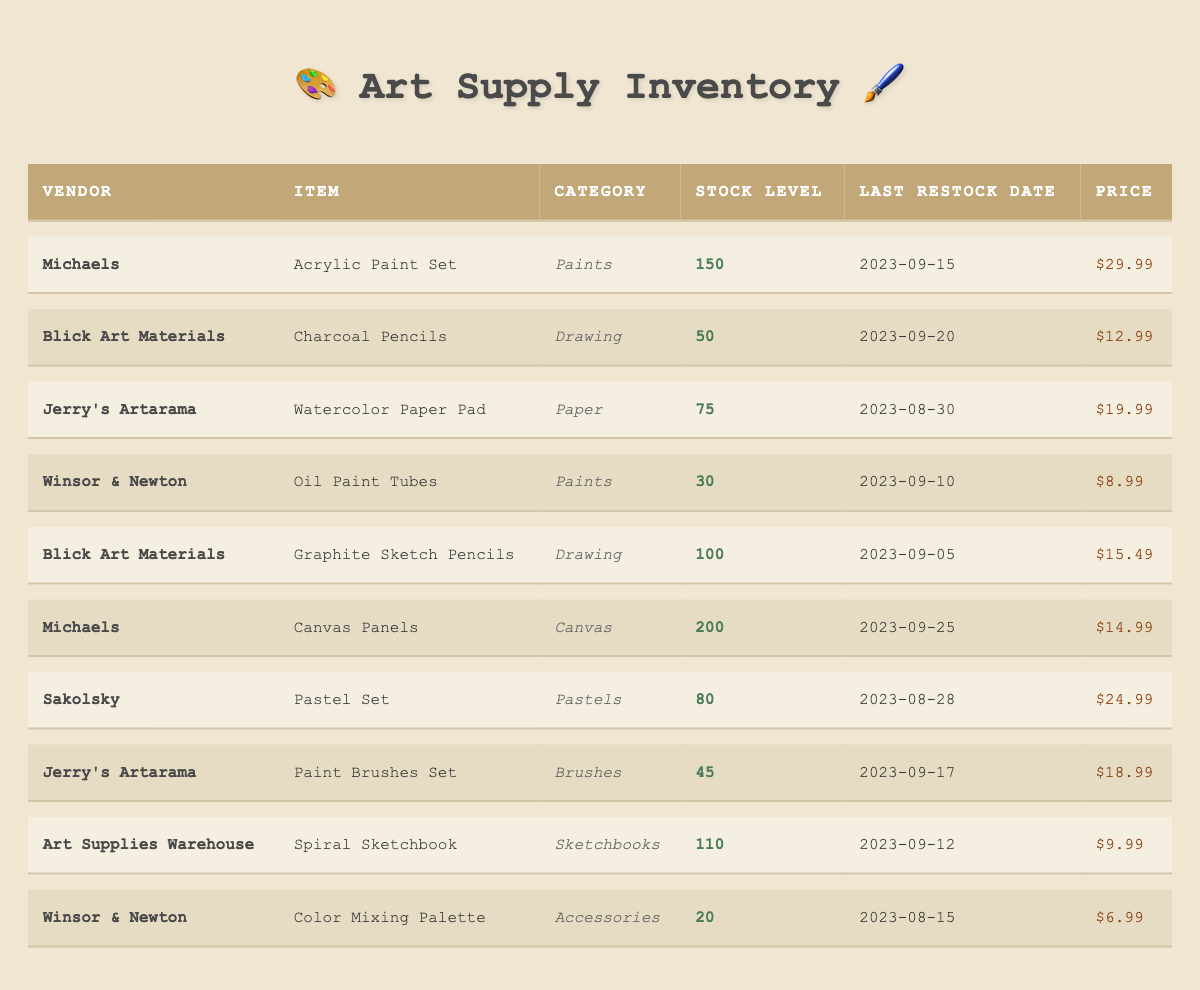What is the stock level of the Canvas Panels from Michaels? The table shows a stock level number for each item. Looking specifically at the row for Michaels' Canvas Panels, the stock level is 200.
Answer: 200 Which item has the lowest stock level? I review the stock levels of all items listed. The lowest stock level is 20 for Winsor & Newton's Color Mixing Palette.
Answer: 20 How many items from Blick Art Materials are listed in the table? By scanning the vendor column, I find that Blick Art Materials appears for two items: Charcoal Pencils and Graphite Sketch Pencils. Hence, there are 2 items from Blick Art Materials.
Answer: 2 What is the average price of the items listed under the category 'Paints'? I find the items categorized as 'Paints': Acrylic Paint Set ($29.99) and Oil Paint Tubes ($8.99). I sum their prices: 29.99 + 8.99 = 38.98. There are 2 items, so the average is 38.98 / 2 = 19.49.
Answer: 19.49 Is there more stock available for Graphite Sketch Pencils than for Watercolor Paper Pad? The stock level for Graphite Sketch Pencils is 100, while for Watercolor Paper Pad, it is 75. Since 100 > 75, the statement is true.
Answer: Yes Which vendor has the highest stock level across all their items in this table? I check each vendor and their stock levels. Michaels has 150 (Acrylic Paint Set) + 200 (Canvas Panels) = 350, Blick Art Materials has 50 + 100 = 150, Jerry's Artarama has 75 + 45 = 120, Winsor & Newton has 30 + 20 = 50, and Sakolsky has 80. Michaels leads with 350, thus it has the highest stock.
Answer: Michaels How much would it cost to purchase one of each item from Art Supplies Warehouse? The only item listed for Art Supplies Warehouse is the Spiral Sketchbook priced at $9.99. Thus, the total cost for one item is simply $9.99.
Answer: $9.99 What is the total stock level for all items listed in the category 'Brushes'? The only item under 'Brushes' is the Paint Brushes Set from Jerry's Artarama, which has a stock level of 45. Therefore, the total stock level for Brushes is 45.
Answer: 45 How many items have been restocked after September 15, 2023? I review the last restock dates: on or after September 15, there are Canvas Panels (Michaels, 2023-09-25), Pastel Set (Sakolsky, 2023-08-28), and Paint Brushes Set (Jerry's Artarama, 2023-09-17). That is 3 items restocked after September 15, 2023.
Answer: 3 Is the price of Oil Paint Tubes less than $10? The table indicates the price for Oil Paint Tubes is $8.99, which is indeed less than $10, confirming the statement.
Answer: Yes 